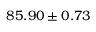Convert formula to latex. <formula><loc_0><loc_0><loc_500><loc_500>8 5 . 9 0 \pm 0 . 7 3</formula> 